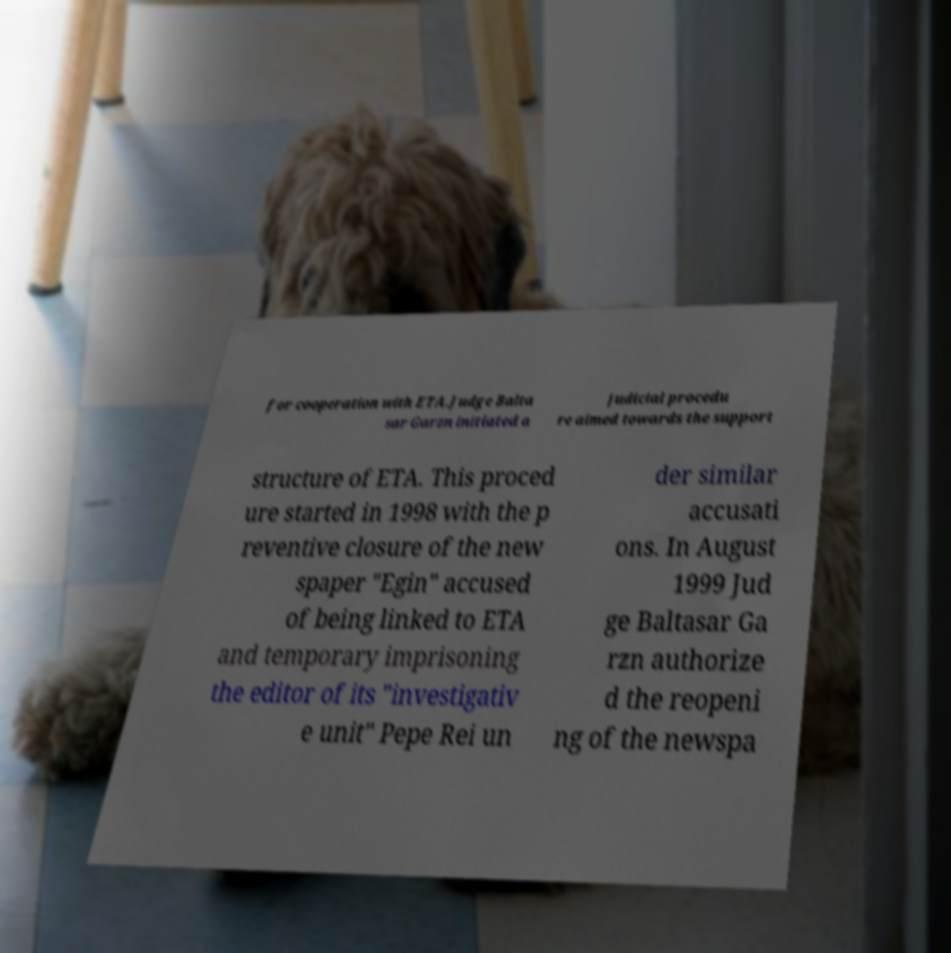For documentation purposes, I need the text within this image transcribed. Could you provide that? for cooperation with ETA.Judge Balta sar Garzn initiated a judicial procedu re aimed towards the support structure of ETA. This proced ure started in 1998 with the p reventive closure of the new spaper "Egin" accused of being linked to ETA and temporary imprisoning the editor of its "investigativ e unit" Pepe Rei un der similar accusati ons. In August 1999 Jud ge Baltasar Ga rzn authorize d the reopeni ng of the newspa 